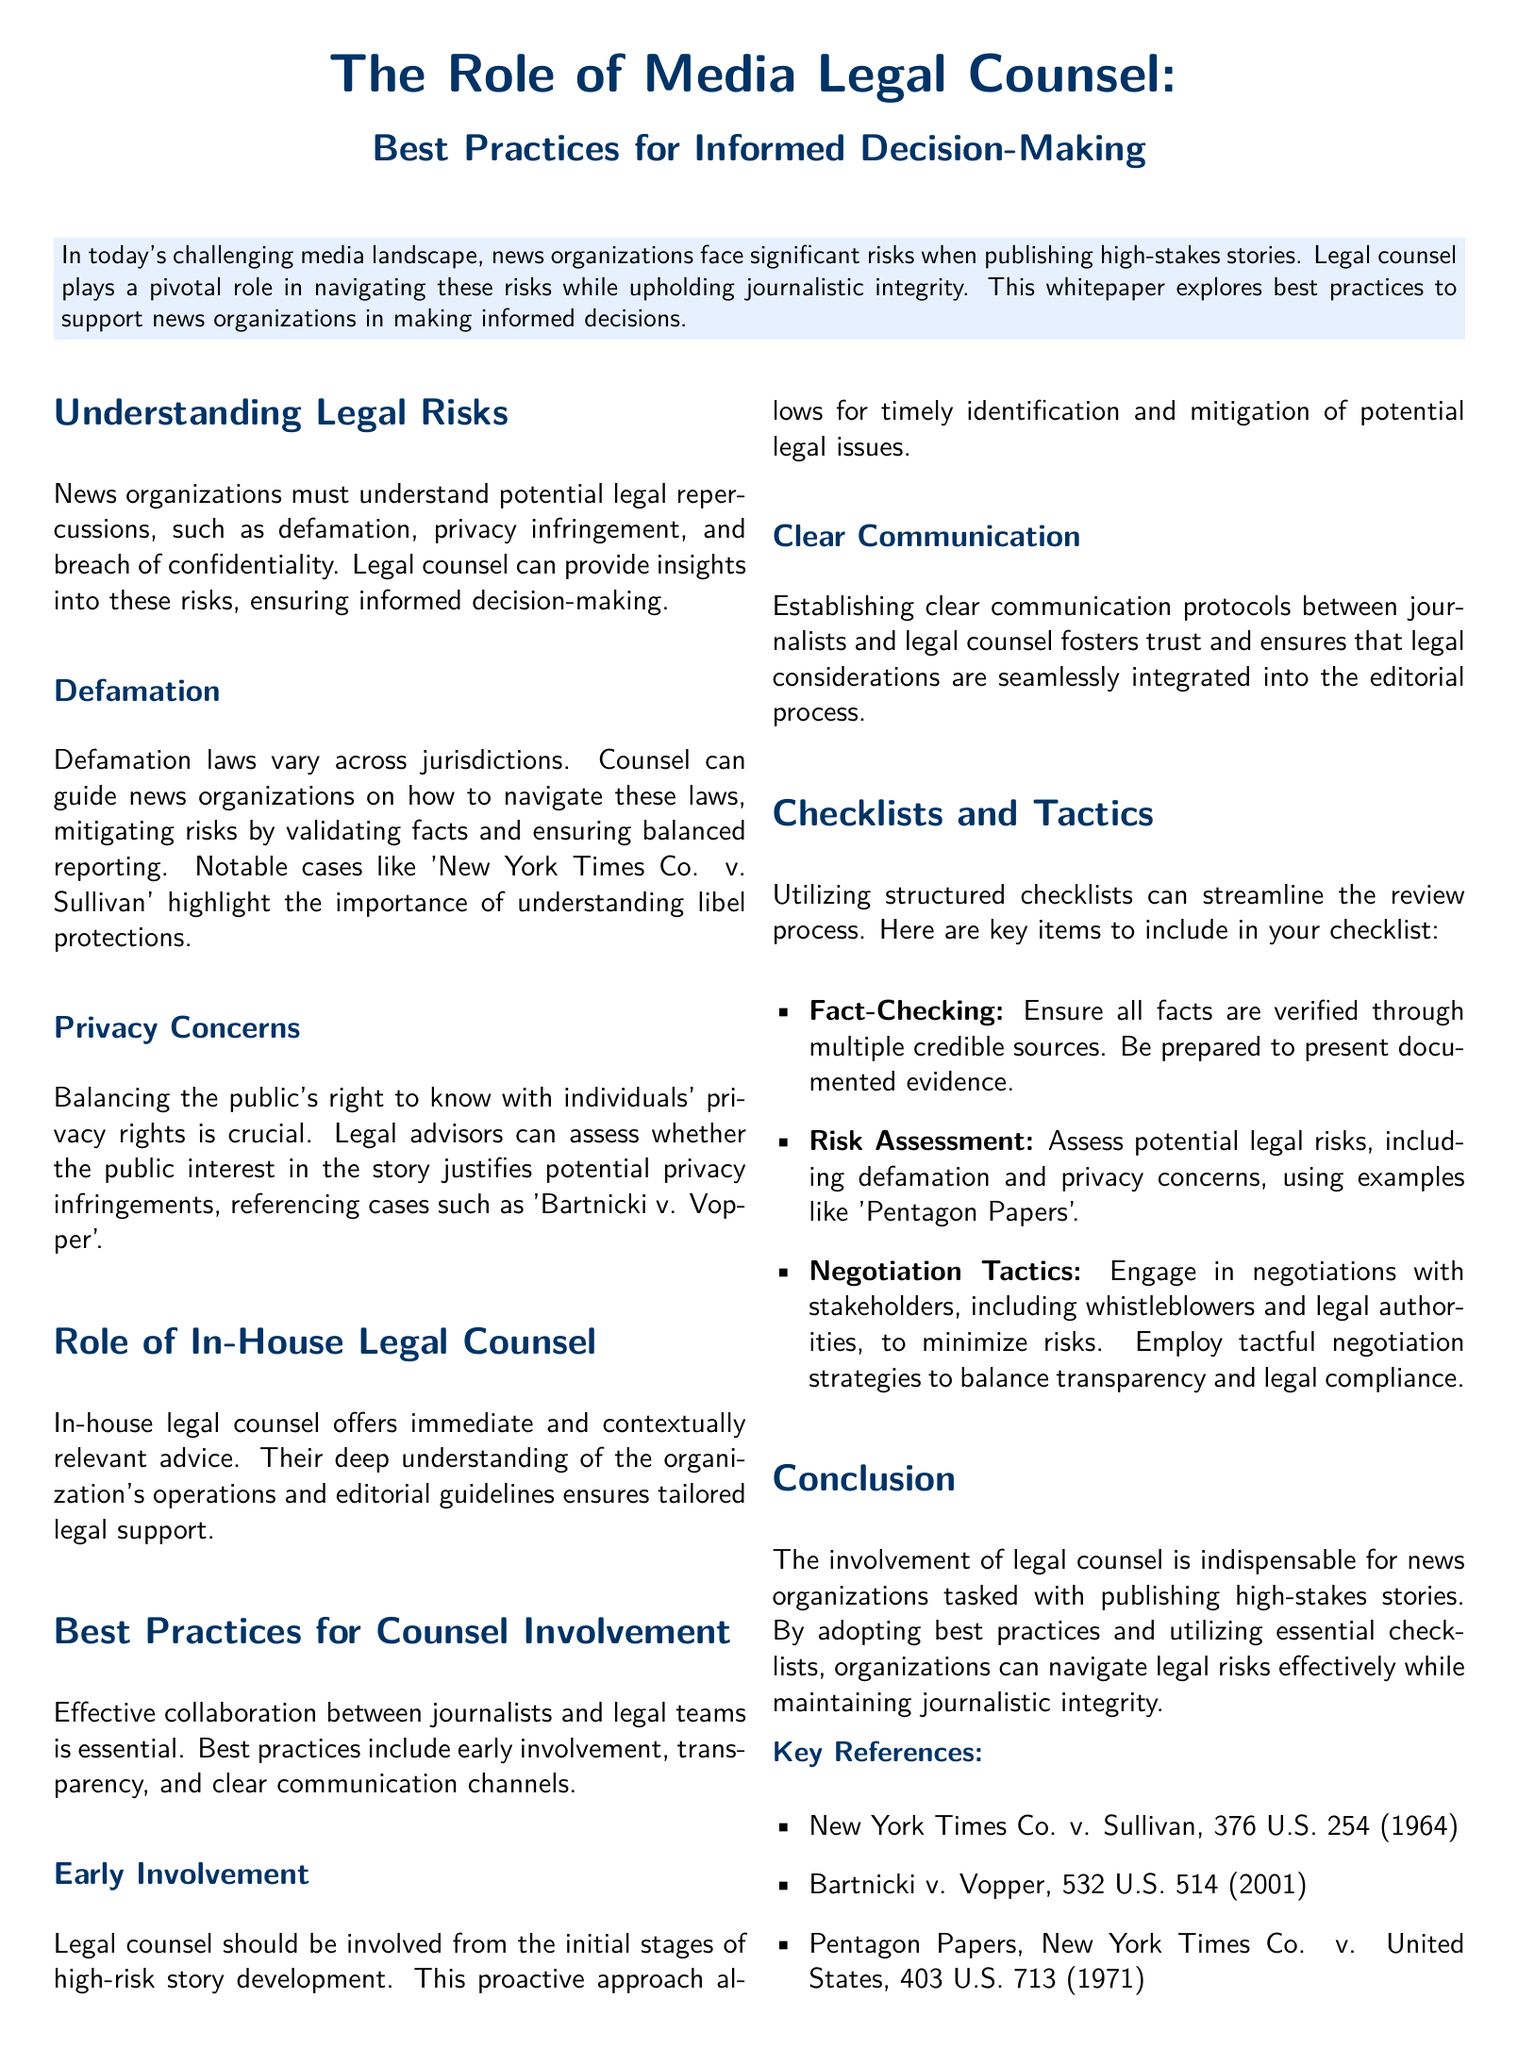What are the potential legal repercussions mentioned? The document lists defamation, privacy infringement, and breach of confidentiality as potential legal repercussions that news organizations must understand.
Answer: defamation, privacy infringement, breach of confidentiality Which case highlights the importance of understanding libel protections? The document references 'New York Times Co. v. Sullivan' as a notable case that highlights the importance of understanding libel protections.
Answer: New York Times Co. v. Sullivan What is the section about early involvement related to? The section on early involvement emphasizes that legal counsel should be involved from the initial stages of high-risk story development to mitigate potential legal issues.
Answer: high-risk story development Which key item in the checklist involves verifying facts? The checklist includes 'Fact-Checking' as the key item that involves ensuring all facts are verified through multiple credible sources.
Answer: Fact-Checking What is the role of in-house legal counsel? The document states that in-house legal counsel offers immediate and contextually relevant advice tailored to the organization's operations and editorial guidelines.
Answer: immediate and contextually relevant advice 